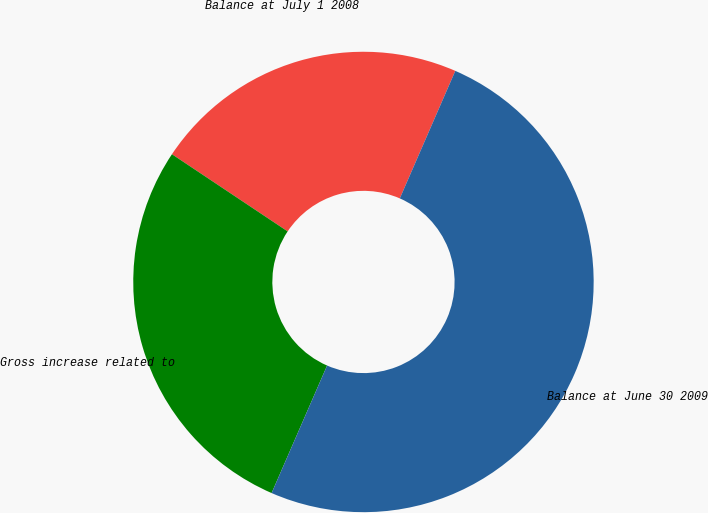<chart> <loc_0><loc_0><loc_500><loc_500><pie_chart><fcel>Balance at July 1 2008<fcel>Gross increase related to<fcel>Balance at June 30 2009<nl><fcel>22.17%<fcel>27.83%<fcel>50.0%<nl></chart> 